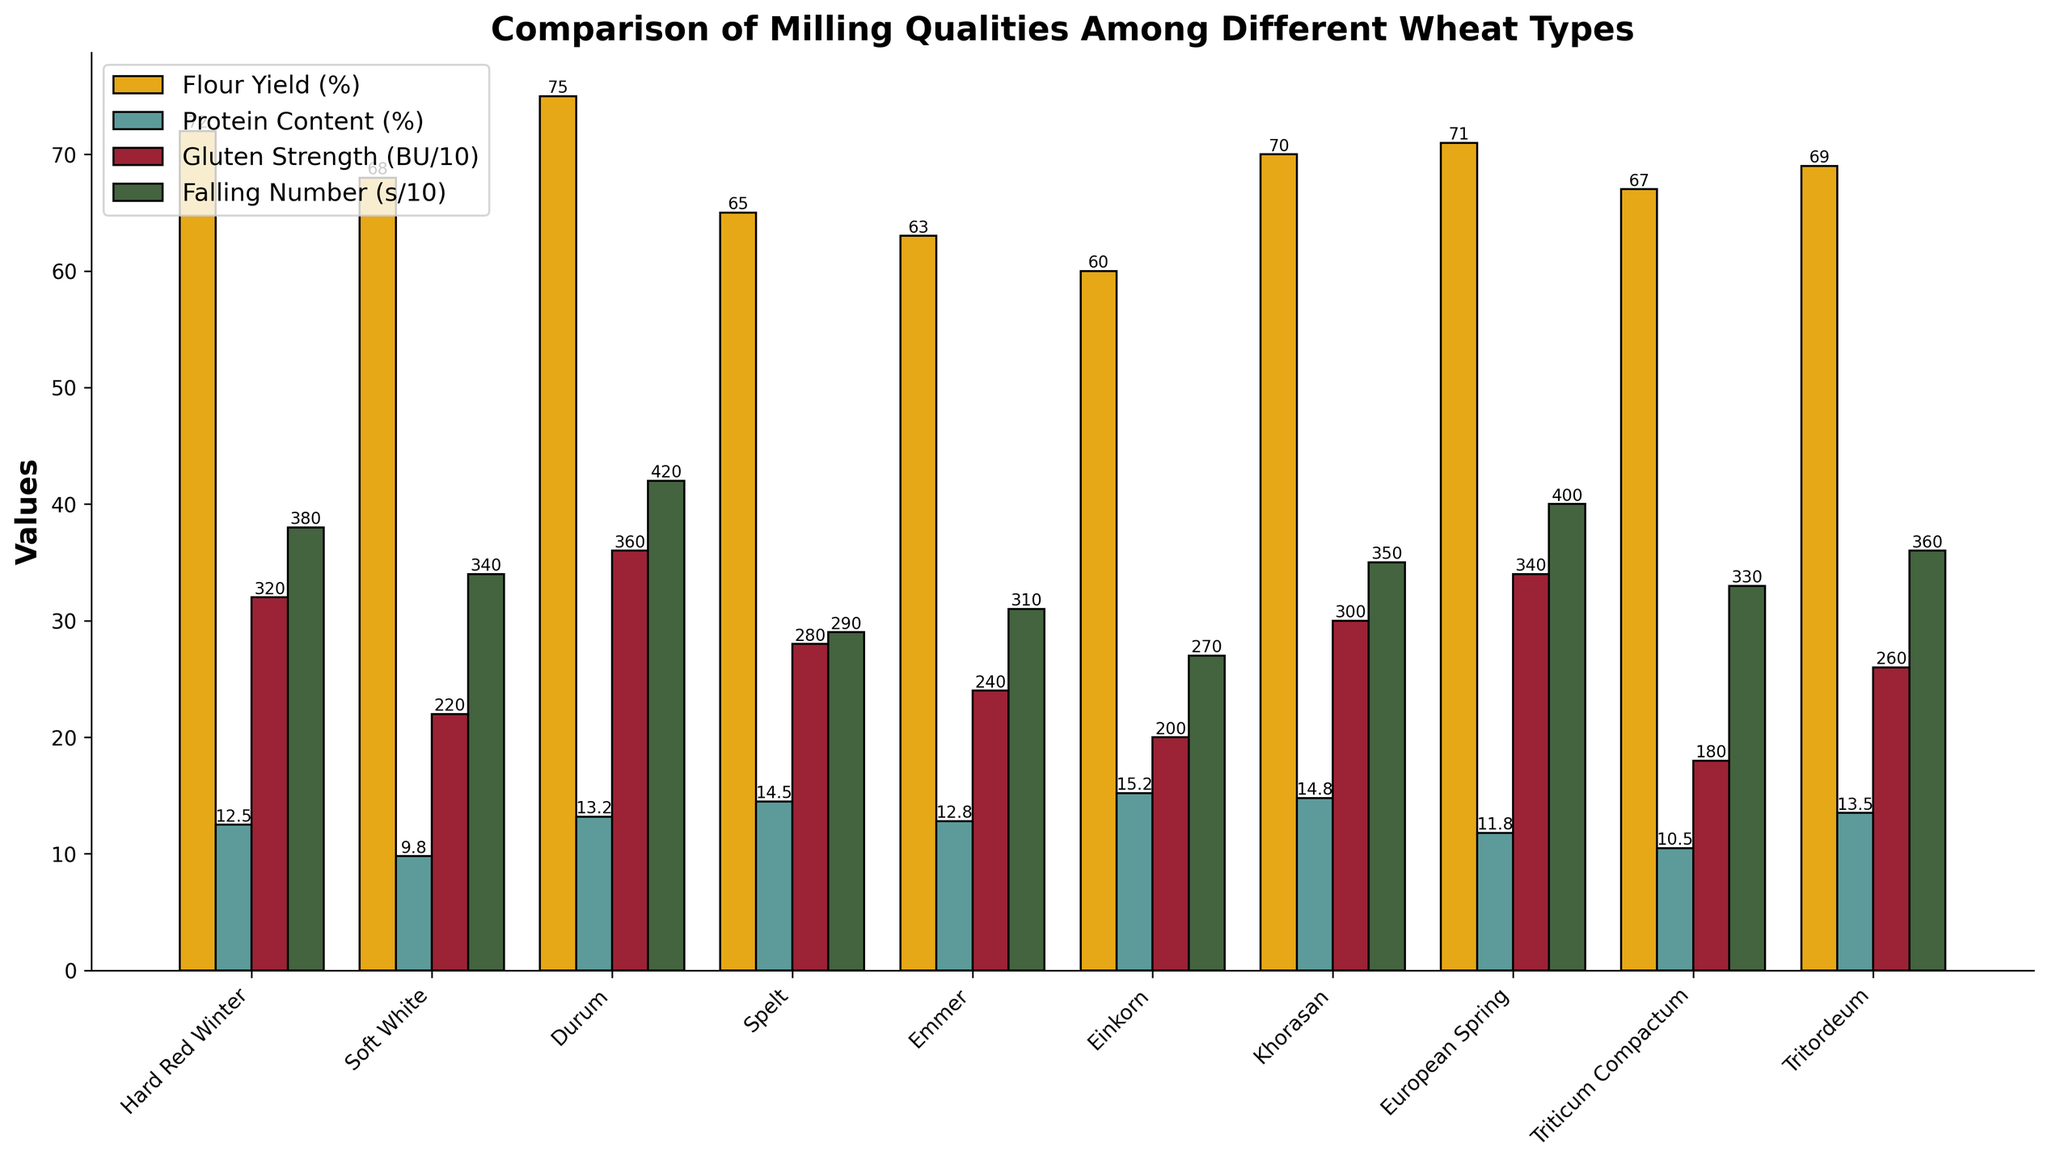Which wheat variety has the highest flour yield? The wheat variety with the highest bar in the "Flour Yield (%)" category is the one with the highest flour yield.
Answer: Durum Which wheat variety has the highest protein content? The wheat variety with the highest bar in the "Protein Content (%)" category is the one with the highest protein content.
Answer: Einkorn What is the difference in gluten strength between Durum and Triticum Compactum? Locate the bars corresponding to Durum and Triticum Compactum in the "Gluten Strength (BU/10)" category and subtract their values. Durum is 36 and Triticum Compactum is 18, the difference is 36 - 18.
Answer: 18 Which wheat type has the lowest falling number? The wheat variety with the smallest bar in the "Falling Number (s/10)" category indicates the lowest falling number.
Answer: Einkorn Compare the protein content of Khorasan and Soft White. Which one is higher and by how much? Locate the bars corresponding to Khorasan and Soft White in the "Protein Content (%)" category. Khorasan is 14.8% and Soft White is 9.8%, the difference is 14.8 - 9.8. Khorasan has higher protein content.
Answer: Khorasan by 5% Which wheat variety has a higher flour yield, Spelt or European Spring, and by how much? Locate the bars corresponding to Spelt and European Spring in the "Flour Yield (%)" category. Spelt is 65% and European Spring is 71%, the difference is 71 - 65.
Answer: European Spring by 6% Which wheat type has the second highest gluten strength? Sort the wheat varieties based on the height of the bars in the "Gluten Strength (BU/10)" category. The second highest bar after Durum (36) belongs to European Spring (34).
Answer: European Spring What is the sum of flour yields for Hard Red Winter and Tritordeum? Sum the heights of the bars in the "Flour Yield (%)" category for Hard Red Winter (72%) and Tritordeum (69%). 72 + 69 = 141.
Answer: 141 Which wheat variety shows the greatest difference between protein content and gluten strength? Calculate the difference between the "Protein Content (%)" and the "Gluten Strength (BU/10)" for each variety. The greatest difference is found by comparing these values across all varieties. Einkorn: 15.2 - 20 = -4.8, is the greatest negative difference.
Answer: Einkorn 